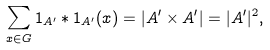<formula> <loc_0><loc_0><loc_500><loc_500>\sum _ { x \in G } { 1 _ { A ^ { \prime } } \ast 1 _ { A ^ { \prime } } ( x ) } = | A ^ { \prime } \times A ^ { \prime } | = | A ^ { \prime } | ^ { 2 } ,</formula> 